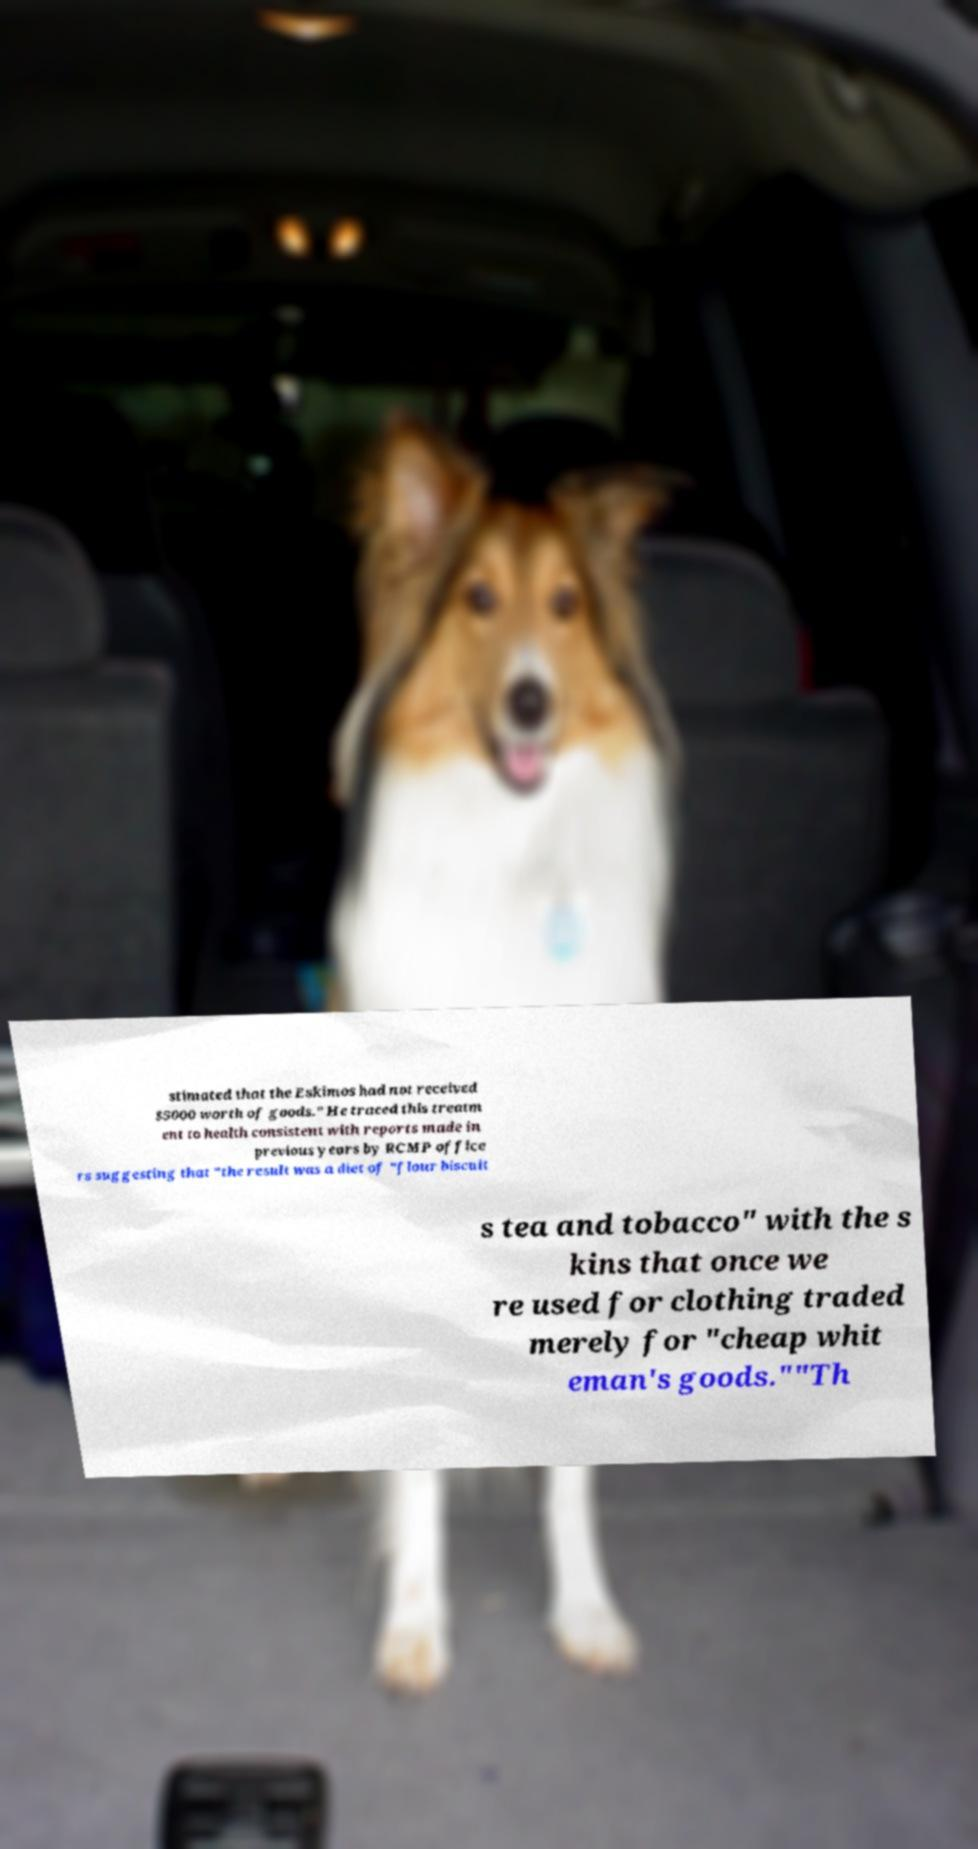What messages or text are displayed in this image? I need them in a readable, typed format. stimated that the Eskimos had not received $5000 worth of goods." He traced this treatm ent to health consistent with reports made in previous years by RCMP office rs suggesting that "the result was a diet of "flour biscuit s tea and tobacco" with the s kins that once we re used for clothing traded merely for "cheap whit eman's goods.""Th 